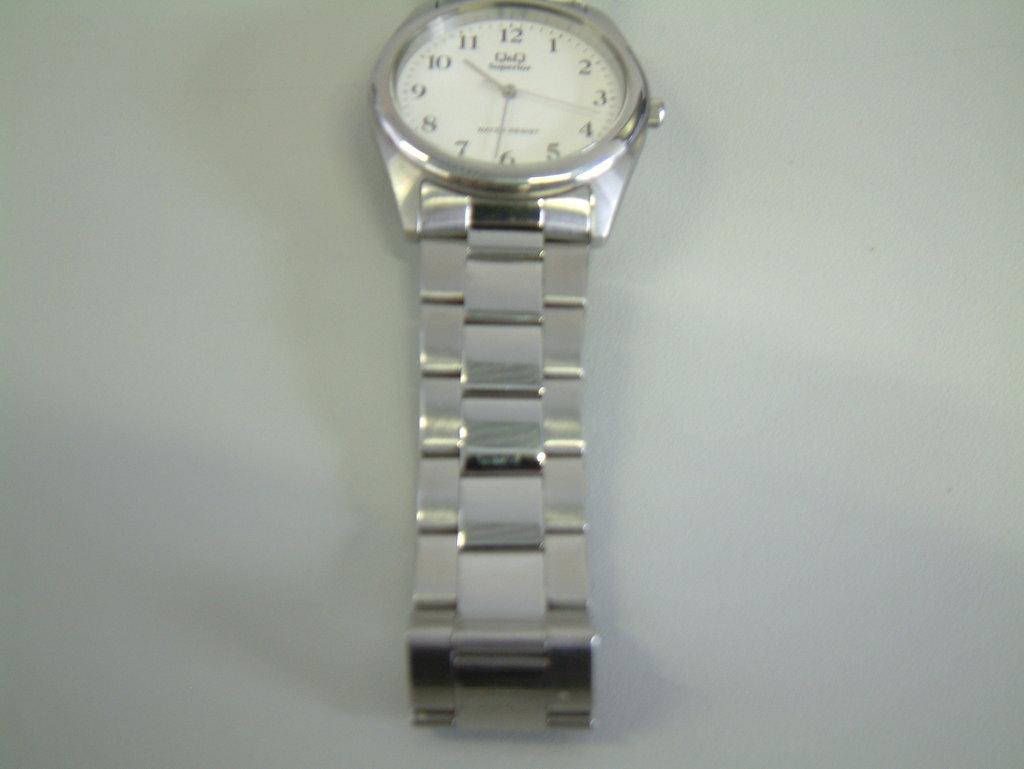The watch shows what time?
Offer a very short reply. 10:31. What brand of watch?
Make the answer very short. Unanswerable. 